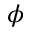Convert formula to latex. <formula><loc_0><loc_0><loc_500><loc_500>\phi</formula> 